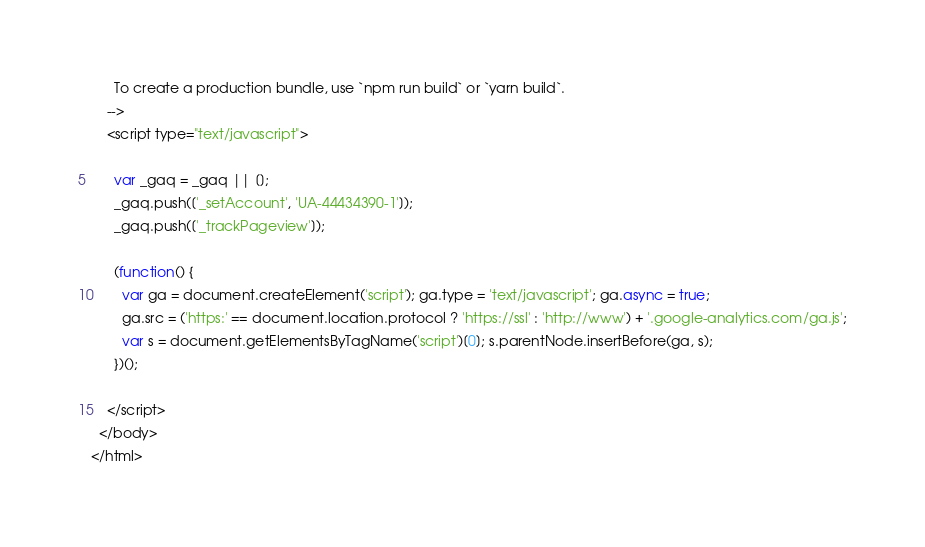Convert code to text. <code><loc_0><loc_0><loc_500><loc_500><_HTML_>      To create a production bundle, use `npm run build` or `yarn build`.
    -->
    <script type="text/javascript">

      var _gaq = _gaq || [];
      _gaq.push(['_setAccount', 'UA-44434390-1']);
      _gaq.push(['_trackPageview']);
    
      (function() {
        var ga = document.createElement('script'); ga.type = 'text/javascript'; ga.async = true;
        ga.src = ('https:' == document.location.protocol ? 'https://ssl' : 'http://www') + '.google-analytics.com/ga.js';
        var s = document.getElementsByTagName('script')[0]; s.parentNode.insertBefore(ga, s);
      })();
    
    </script>
  </body>
</html>
</code> 